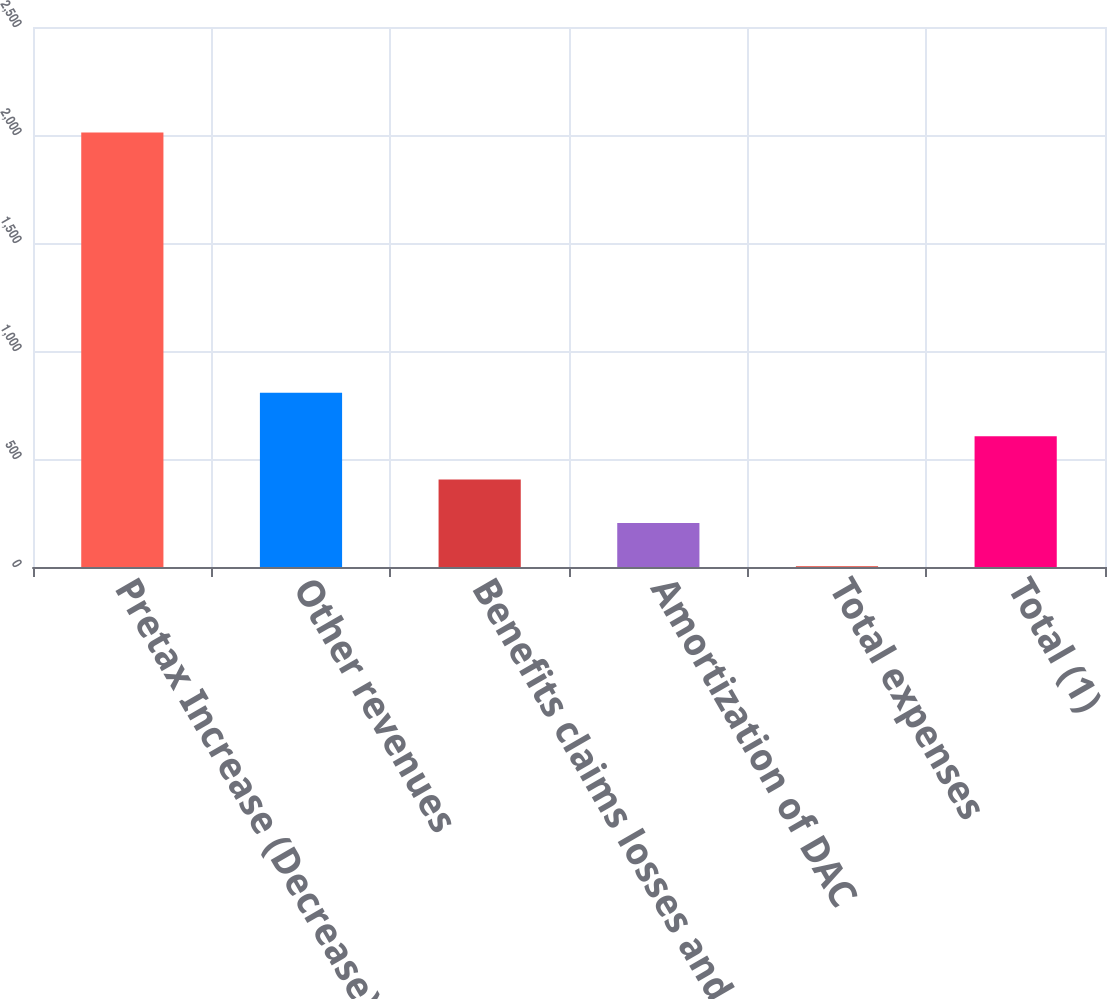<chart> <loc_0><loc_0><loc_500><loc_500><bar_chart><fcel>Pretax Increase (Decrease)<fcel>Other revenues<fcel>Benefits claims losses and<fcel>Amortization of DAC<fcel>Total expenses<fcel>Total (1)<nl><fcel>2012<fcel>806.6<fcel>404.8<fcel>203.9<fcel>3<fcel>605.7<nl></chart> 